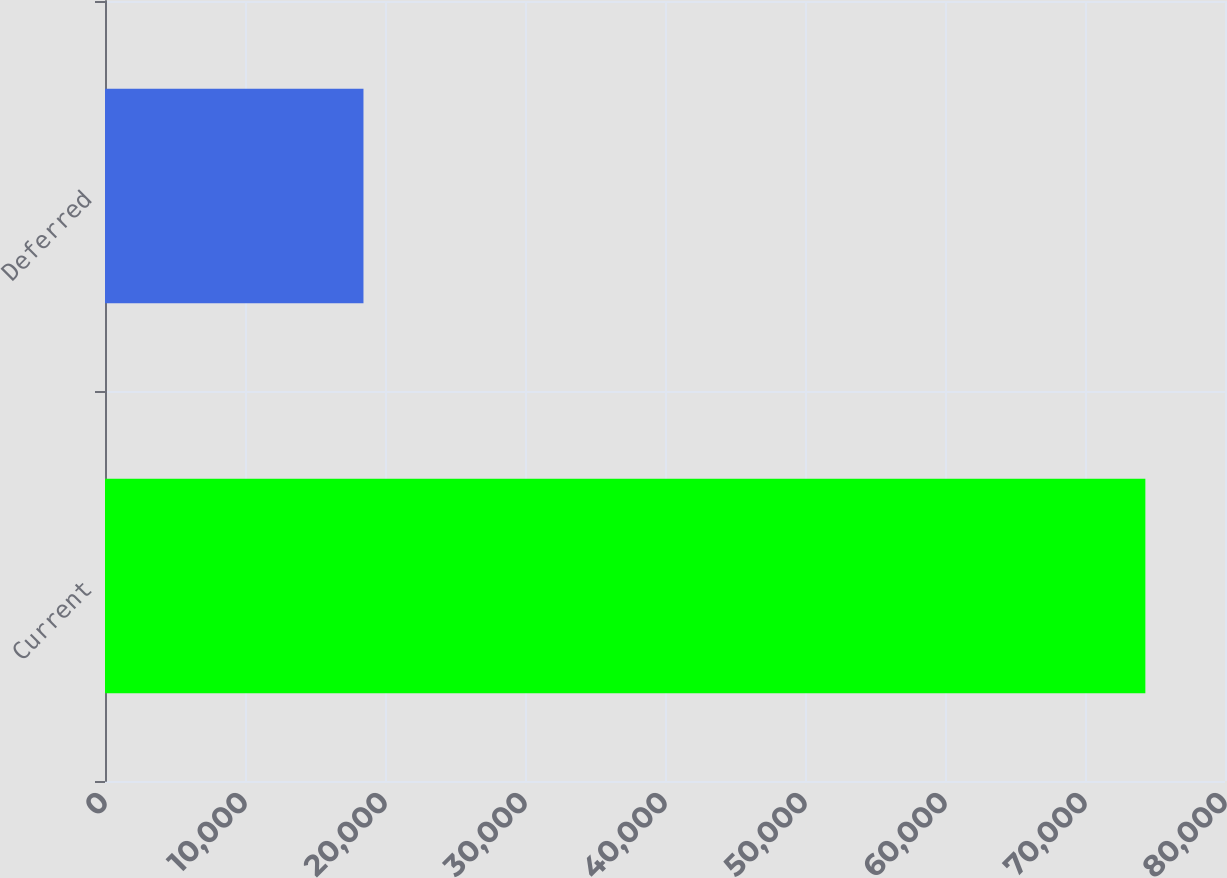Convert chart to OTSL. <chart><loc_0><loc_0><loc_500><loc_500><bar_chart><fcel>Current<fcel>Deferred<nl><fcel>74311<fcel>18462<nl></chart> 